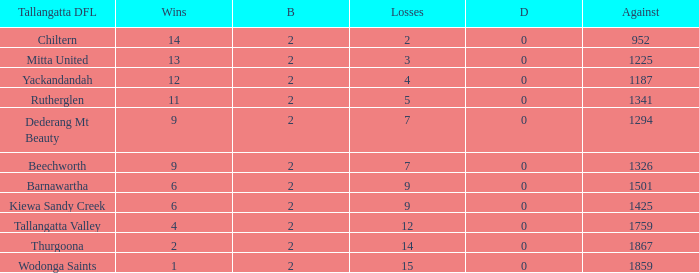Parse the full table. {'header': ['Tallangatta DFL', 'Wins', 'B', 'Losses', 'D', 'Against'], 'rows': [['Chiltern', '14', '2', '2', '0', '952'], ['Mitta United', '13', '2', '3', '0', '1225'], ['Yackandandah', '12', '2', '4', '0', '1187'], ['Rutherglen', '11', '2', '5', '0', '1341'], ['Dederang Mt Beauty', '9', '2', '7', '0', '1294'], ['Beechworth', '9', '2', '7', '0', '1326'], ['Barnawartha', '6', '2', '9', '0', '1501'], ['Kiewa Sandy Creek', '6', '2', '9', '0', '1425'], ['Tallangatta Valley', '4', '2', '12', '0', '1759'], ['Thurgoona', '2', '2', '14', '0', '1867'], ['Wodonga Saints', '1', '2', '15', '0', '1859']]} What are the losses when there are 9 wins and more than 1326 against? None. 